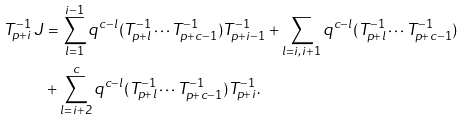Convert formula to latex. <formula><loc_0><loc_0><loc_500><loc_500>T _ { p + i } ^ { - 1 } \, J & = \sum _ { l = 1 } ^ { i - 1 } q ^ { c - l } ( T _ { p + l } ^ { - 1 } \cdots T _ { p + c - 1 } ^ { - 1 } ) T _ { p + i - 1 } ^ { - 1 } + \sum _ { l = i , i + 1 } q ^ { c - l } ( T _ { p + l } ^ { - 1 } \cdots T _ { p + c - 1 } ^ { - 1 } ) \\ & + \sum _ { l = i + 2 } ^ { c } q ^ { c - l } ( T _ { p + l } ^ { - 1 } \cdots T _ { p + c - 1 } ^ { - 1 } ) T _ { p + i } ^ { - 1 } .</formula> 